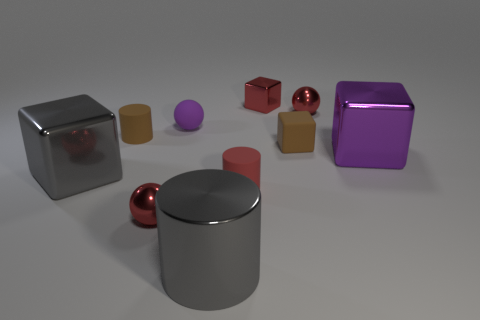Is there anything else that has the same material as the purple ball?
Keep it short and to the point. Yes. There is a small metallic sphere in front of the large purple metallic cube; is its color the same as the small cylinder that is on the left side of the rubber ball?
Provide a short and direct response. No. What number of small red objects are both left of the purple matte object and on the right side of the purple matte sphere?
Offer a terse response. 0. What number of other objects are there of the same shape as the purple matte thing?
Offer a very short reply. 2. Is the number of small red metallic cubes that are left of the red block greater than the number of big blue metallic objects?
Your response must be concise. No. There is a large metallic object behind the big gray shiny block; what is its color?
Your response must be concise. Purple. What size is the thing that is the same color as the small rubber block?
Provide a succinct answer. Small. What number of matte objects are either big purple things or big cubes?
Ensure brevity in your answer.  0. There is a brown object that is right of the metal block behind the small purple matte object; are there any matte balls that are on the right side of it?
Keep it short and to the point. No. There is a brown block; what number of small brown cubes are to the left of it?
Ensure brevity in your answer.  0. 